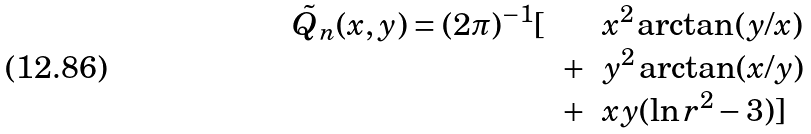Convert formula to latex. <formula><loc_0><loc_0><loc_500><loc_500>\begin{array} { l c l } \tilde { Q } _ { n } ( x , y ) = ( 2 \pi ) ^ { - 1 } [ & & x ^ { 2 } \arctan ( y / x ) \\ & + & y ^ { 2 } \arctan ( x / y ) \\ & + & x y ( \ln r ^ { 2 } - 3 ) ] \end{array}</formula> 